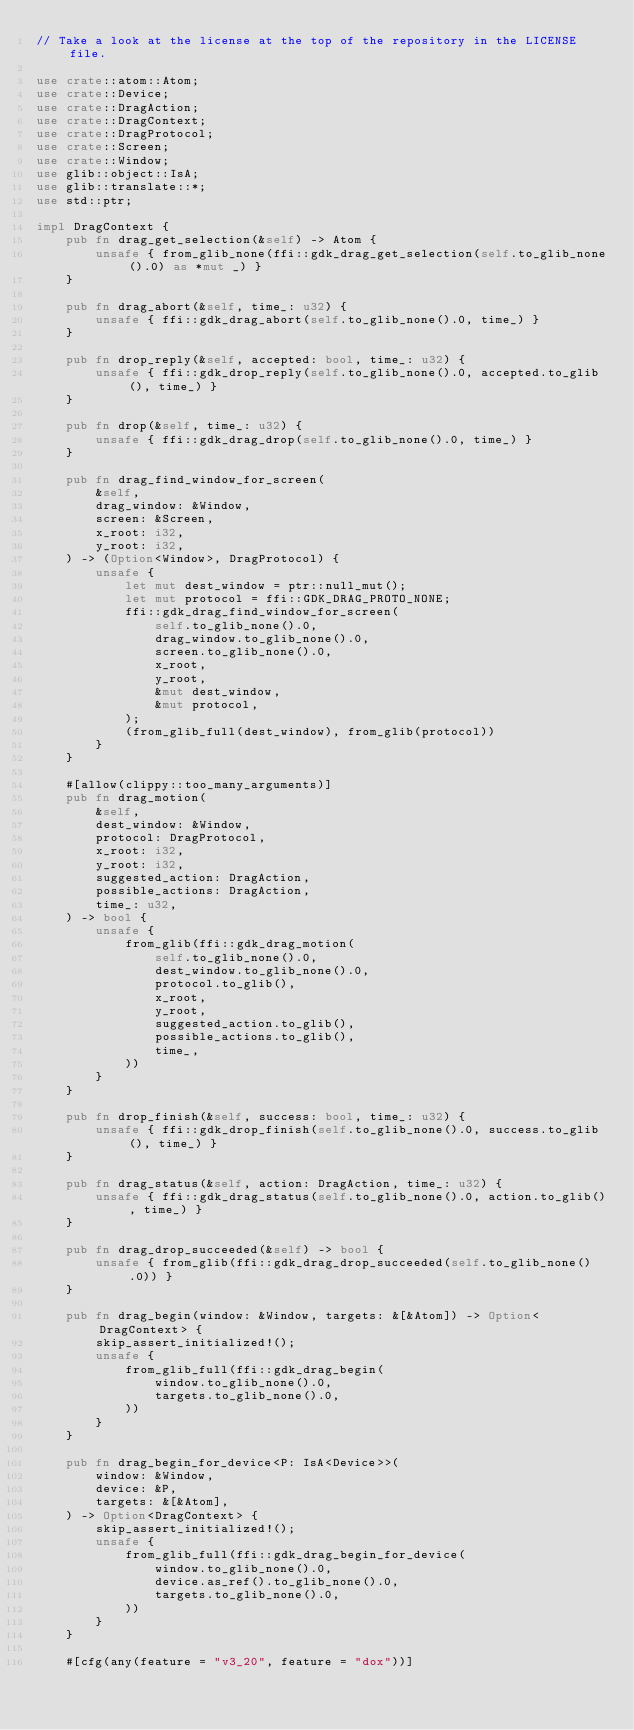<code> <loc_0><loc_0><loc_500><loc_500><_Rust_>// Take a look at the license at the top of the repository in the LICENSE file.

use crate::atom::Atom;
use crate::Device;
use crate::DragAction;
use crate::DragContext;
use crate::DragProtocol;
use crate::Screen;
use crate::Window;
use glib::object::IsA;
use glib::translate::*;
use std::ptr;

impl DragContext {
    pub fn drag_get_selection(&self) -> Atom {
        unsafe { from_glib_none(ffi::gdk_drag_get_selection(self.to_glib_none().0) as *mut _) }
    }

    pub fn drag_abort(&self, time_: u32) {
        unsafe { ffi::gdk_drag_abort(self.to_glib_none().0, time_) }
    }

    pub fn drop_reply(&self, accepted: bool, time_: u32) {
        unsafe { ffi::gdk_drop_reply(self.to_glib_none().0, accepted.to_glib(), time_) }
    }

    pub fn drop(&self, time_: u32) {
        unsafe { ffi::gdk_drag_drop(self.to_glib_none().0, time_) }
    }

    pub fn drag_find_window_for_screen(
        &self,
        drag_window: &Window,
        screen: &Screen,
        x_root: i32,
        y_root: i32,
    ) -> (Option<Window>, DragProtocol) {
        unsafe {
            let mut dest_window = ptr::null_mut();
            let mut protocol = ffi::GDK_DRAG_PROTO_NONE;
            ffi::gdk_drag_find_window_for_screen(
                self.to_glib_none().0,
                drag_window.to_glib_none().0,
                screen.to_glib_none().0,
                x_root,
                y_root,
                &mut dest_window,
                &mut protocol,
            );
            (from_glib_full(dest_window), from_glib(protocol))
        }
    }

    #[allow(clippy::too_many_arguments)]
    pub fn drag_motion(
        &self,
        dest_window: &Window,
        protocol: DragProtocol,
        x_root: i32,
        y_root: i32,
        suggested_action: DragAction,
        possible_actions: DragAction,
        time_: u32,
    ) -> bool {
        unsafe {
            from_glib(ffi::gdk_drag_motion(
                self.to_glib_none().0,
                dest_window.to_glib_none().0,
                protocol.to_glib(),
                x_root,
                y_root,
                suggested_action.to_glib(),
                possible_actions.to_glib(),
                time_,
            ))
        }
    }

    pub fn drop_finish(&self, success: bool, time_: u32) {
        unsafe { ffi::gdk_drop_finish(self.to_glib_none().0, success.to_glib(), time_) }
    }

    pub fn drag_status(&self, action: DragAction, time_: u32) {
        unsafe { ffi::gdk_drag_status(self.to_glib_none().0, action.to_glib(), time_) }
    }

    pub fn drag_drop_succeeded(&self) -> bool {
        unsafe { from_glib(ffi::gdk_drag_drop_succeeded(self.to_glib_none().0)) }
    }

    pub fn drag_begin(window: &Window, targets: &[&Atom]) -> Option<DragContext> {
        skip_assert_initialized!();
        unsafe {
            from_glib_full(ffi::gdk_drag_begin(
                window.to_glib_none().0,
                targets.to_glib_none().0,
            ))
        }
    }

    pub fn drag_begin_for_device<P: IsA<Device>>(
        window: &Window,
        device: &P,
        targets: &[&Atom],
    ) -> Option<DragContext> {
        skip_assert_initialized!();
        unsafe {
            from_glib_full(ffi::gdk_drag_begin_for_device(
                window.to_glib_none().0,
                device.as_ref().to_glib_none().0,
                targets.to_glib_none().0,
            ))
        }
    }

    #[cfg(any(feature = "v3_20", feature = "dox"))]</code> 